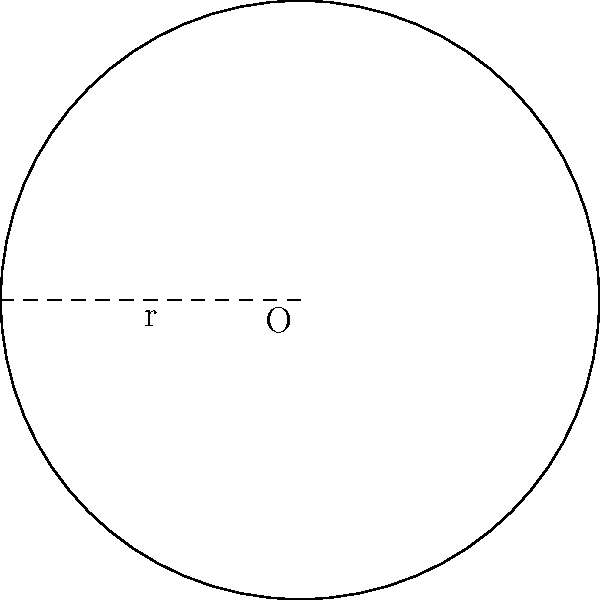As part of a community garden project for fellow refugees, you're planning a circular garden plot. If the radius of the plot is 3 meters, what is the area of the garden in square meters? (Use $\pi \approx 3.14$) To find the area of a circular garden plot, we can follow these steps:

1. Recall the formula for the area of a circle: $A = \pi r^2$, where $A$ is the area and $r$ is the radius.

2. We're given that the radius $r = 3$ meters.

3. Substitute the values into the formula:
   $A = \pi \cdot 3^2$

4. Simplify the exponent:
   $A = \pi \cdot 9$

5. Use the approximation $\pi \approx 3.14$:
   $A \approx 3.14 \cdot 9$

6. Calculate the final result:
   $A \approx 28.26$ square meters

Therefore, the area of the circular garden plot is approximately 28.26 square meters.
Answer: $28.26 \text{ m}^2$ 